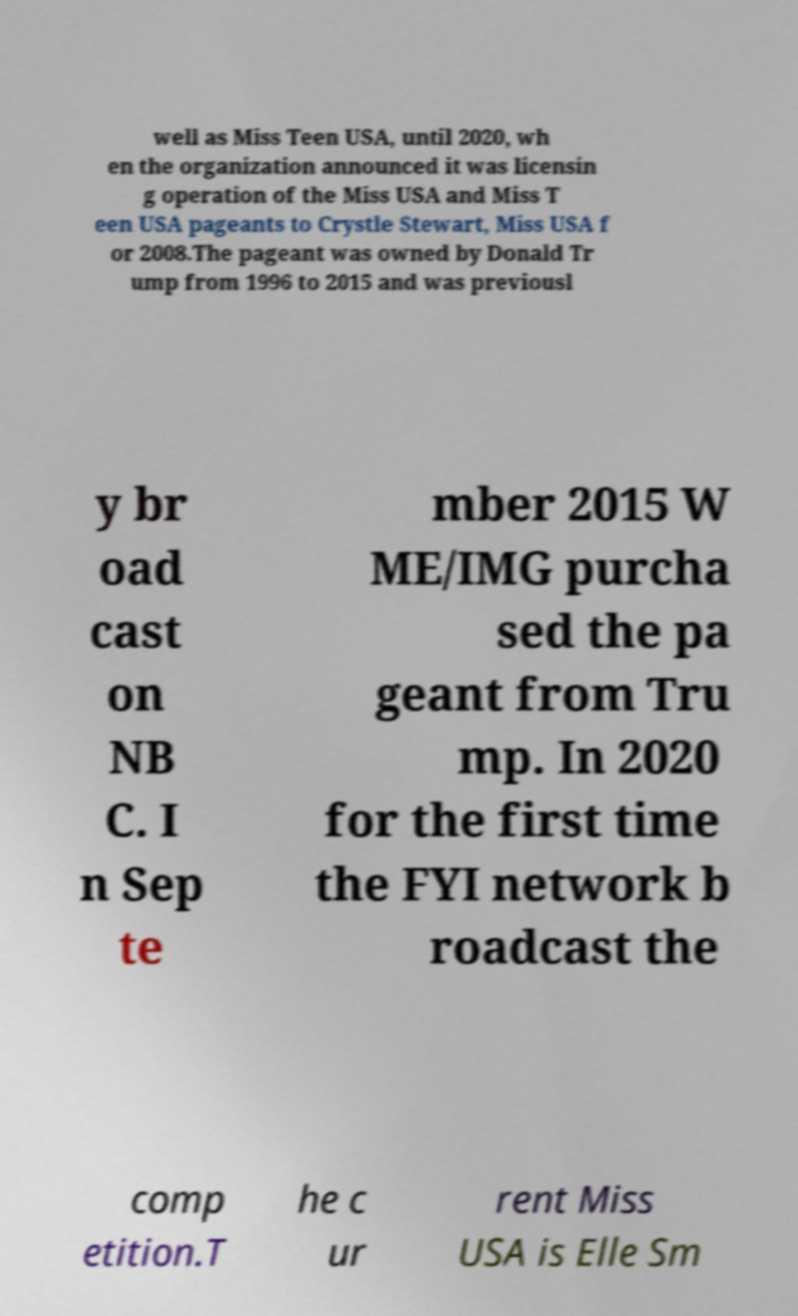Could you extract and type out the text from this image? well as Miss Teen USA, until 2020, wh en the organization announced it was licensin g operation of the Miss USA and Miss T een USA pageants to Crystle Stewart, Miss USA f or 2008.The pageant was owned by Donald Tr ump from 1996 to 2015 and was previousl y br oad cast on NB C. I n Sep te mber 2015 W ME/IMG purcha sed the pa geant from Tru mp. In 2020 for the first time the FYI network b roadcast the comp etition.T he c ur rent Miss USA is Elle Sm 